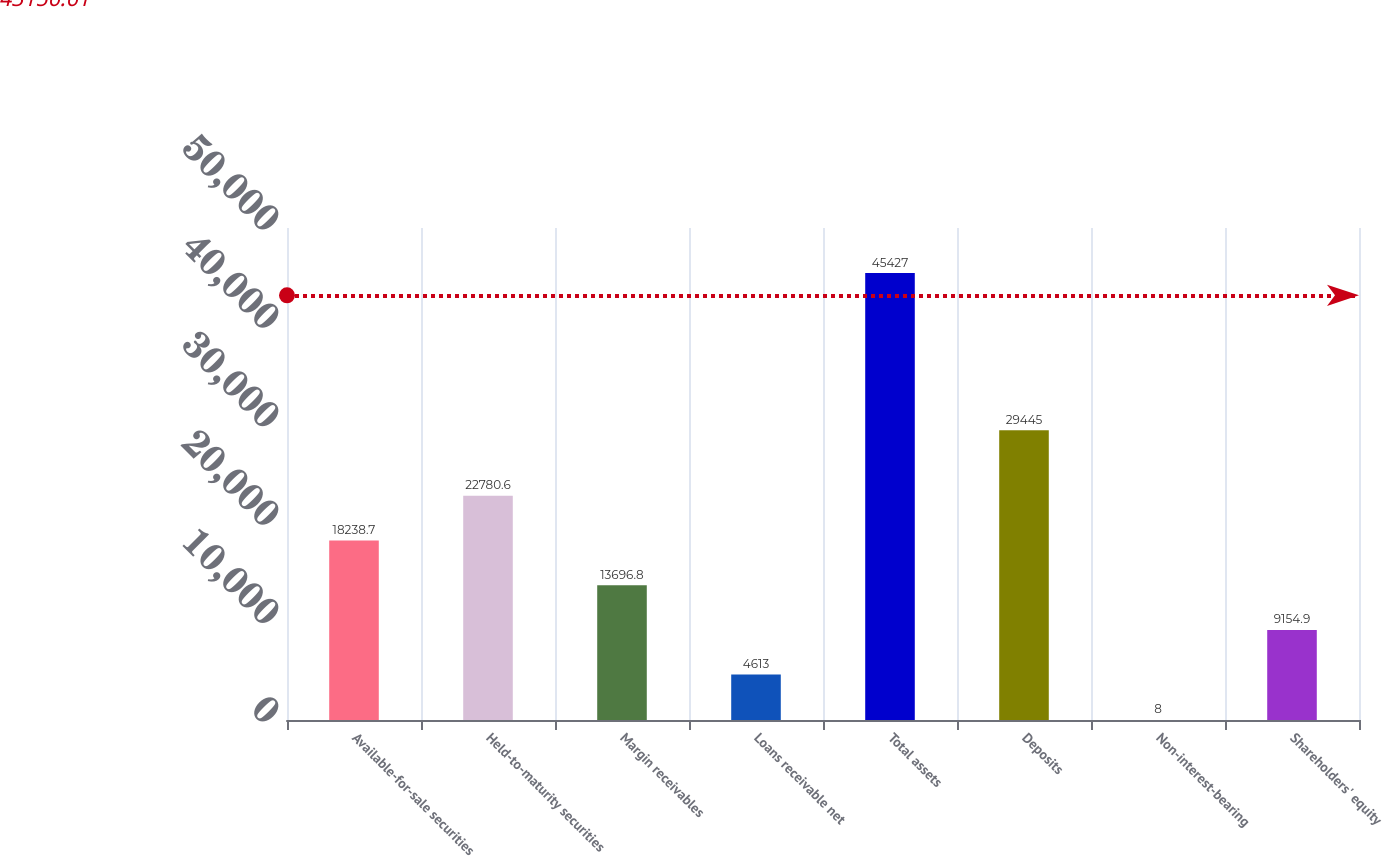Convert chart to OTSL. <chart><loc_0><loc_0><loc_500><loc_500><bar_chart><fcel>Available-for-sale securities<fcel>Held-to-maturity securities<fcel>Margin receivables<fcel>Loans receivable net<fcel>Total assets<fcel>Deposits<fcel>Non-interest-bearing<fcel>Shareholders' equity<nl><fcel>18238.7<fcel>22780.6<fcel>13696.8<fcel>4613<fcel>45427<fcel>29445<fcel>8<fcel>9154.9<nl></chart> 